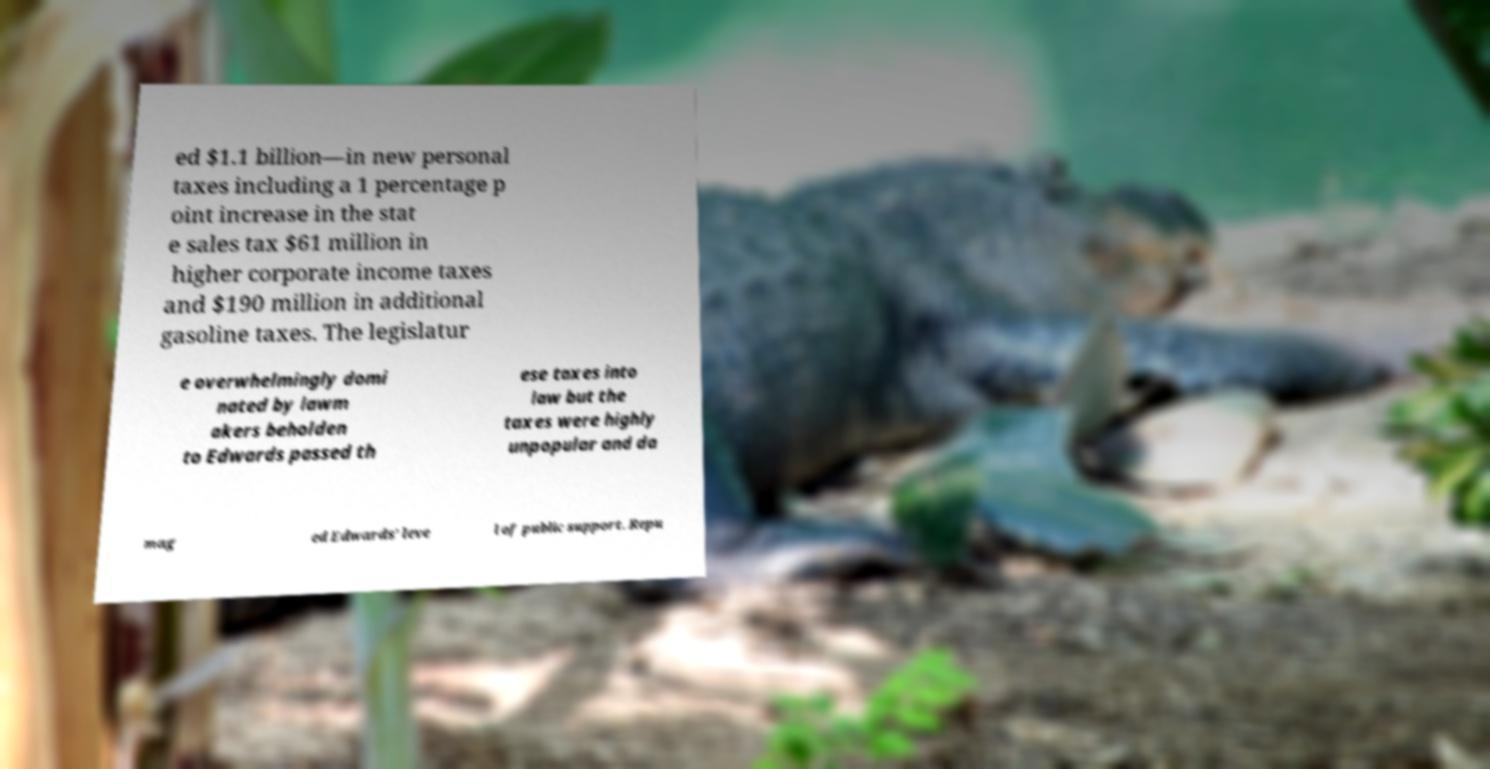There's text embedded in this image that I need extracted. Can you transcribe it verbatim? ed $1.1 billion—in new personal taxes including a 1 percentage p oint increase in the stat e sales tax $61 million in higher corporate income taxes and $190 million in additional gasoline taxes. The legislatur e overwhelmingly domi nated by lawm akers beholden to Edwards passed th ese taxes into law but the taxes were highly unpopular and da mag ed Edwards' leve l of public support. Repu 